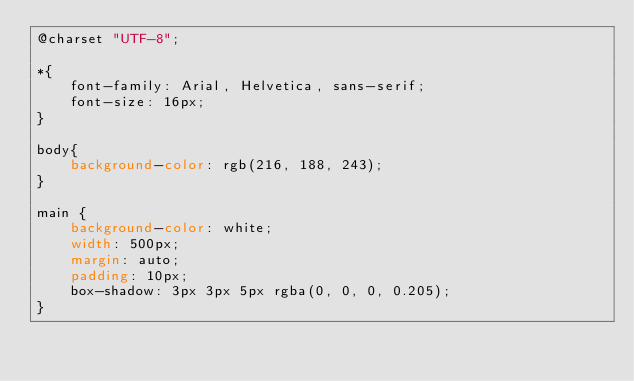Convert code to text. <code><loc_0><loc_0><loc_500><loc_500><_CSS_>@charset "UTF-8";

*{
    font-family: Arial, Helvetica, sans-serif;
    font-size: 16px;
}

body{
    background-color: rgb(216, 188, 243);
}

main {
    background-color: white;
    width: 500px;
    margin: auto;
    padding: 10px;
    box-shadow: 3px 3px 5px rgba(0, 0, 0, 0.205);
}

</code> 